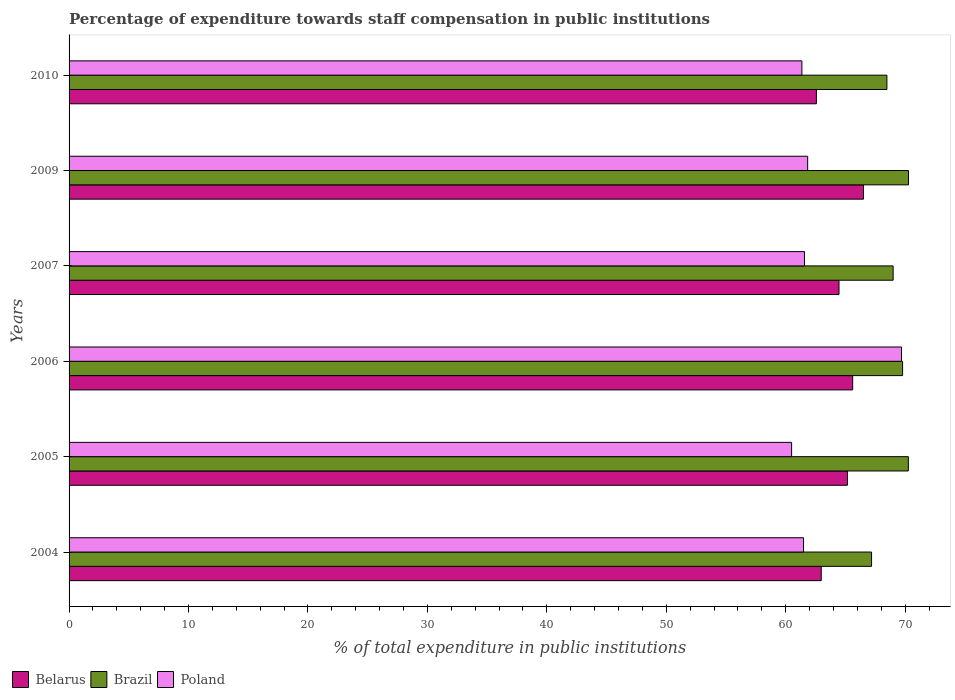How many groups of bars are there?
Provide a short and direct response. 6. Are the number of bars per tick equal to the number of legend labels?
Offer a terse response. Yes. Are the number of bars on each tick of the Y-axis equal?
Give a very brief answer. Yes. What is the percentage of expenditure towards staff compensation in Brazil in 2005?
Keep it short and to the point. 70.27. Across all years, what is the maximum percentage of expenditure towards staff compensation in Poland?
Offer a terse response. 69.7. Across all years, what is the minimum percentage of expenditure towards staff compensation in Poland?
Your answer should be very brief. 60.49. In which year was the percentage of expenditure towards staff compensation in Poland maximum?
Keep it short and to the point. 2006. In which year was the percentage of expenditure towards staff compensation in Poland minimum?
Your answer should be compact. 2005. What is the total percentage of expenditure towards staff compensation in Belarus in the graph?
Keep it short and to the point. 387.28. What is the difference between the percentage of expenditure towards staff compensation in Belarus in 2007 and that in 2010?
Offer a terse response. 1.89. What is the difference between the percentage of expenditure towards staff compensation in Poland in 2004 and the percentage of expenditure towards staff compensation in Belarus in 2005?
Give a very brief answer. -3.67. What is the average percentage of expenditure towards staff compensation in Belarus per year?
Give a very brief answer. 64.55. In the year 2009, what is the difference between the percentage of expenditure towards staff compensation in Poland and percentage of expenditure towards staff compensation in Belarus?
Ensure brevity in your answer.  -4.68. In how many years, is the percentage of expenditure towards staff compensation in Belarus greater than 64 %?
Offer a very short reply. 4. What is the ratio of the percentage of expenditure towards staff compensation in Brazil in 2006 to that in 2007?
Make the answer very short. 1.01. Is the percentage of expenditure towards staff compensation in Poland in 2005 less than that in 2007?
Your answer should be compact. Yes. What is the difference between the highest and the second highest percentage of expenditure towards staff compensation in Poland?
Your response must be concise. 7.86. What is the difference between the highest and the lowest percentage of expenditure towards staff compensation in Belarus?
Provide a short and direct response. 3.94. What does the 3rd bar from the bottom in 2006 represents?
Your response must be concise. Poland. How many years are there in the graph?
Offer a terse response. 6. What is the difference between two consecutive major ticks on the X-axis?
Your answer should be compact. 10. Where does the legend appear in the graph?
Your answer should be very brief. Bottom left. How are the legend labels stacked?
Your response must be concise. Horizontal. What is the title of the graph?
Your answer should be very brief. Percentage of expenditure towards staff compensation in public institutions. What is the label or title of the X-axis?
Make the answer very short. % of total expenditure in public institutions. What is the % of total expenditure in public institutions of Belarus in 2004?
Offer a terse response. 62.97. What is the % of total expenditure in public institutions of Brazil in 2004?
Your answer should be compact. 67.19. What is the % of total expenditure in public institutions in Poland in 2004?
Provide a succinct answer. 61.49. What is the % of total expenditure in public institutions in Belarus in 2005?
Offer a very short reply. 65.17. What is the % of total expenditure in public institutions of Brazil in 2005?
Your answer should be very brief. 70.27. What is the % of total expenditure in public institutions in Poland in 2005?
Your answer should be very brief. 60.49. What is the % of total expenditure in public institutions in Belarus in 2006?
Ensure brevity in your answer.  65.6. What is the % of total expenditure in public institutions in Brazil in 2006?
Your answer should be very brief. 69.78. What is the % of total expenditure in public institutions in Poland in 2006?
Keep it short and to the point. 69.7. What is the % of total expenditure in public institutions in Belarus in 2007?
Offer a very short reply. 64.46. What is the % of total expenditure in public institutions in Brazil in 2007?
Offer a very short reply. 68.99. What is the % of total expenditure in public institutions in Poland in 2007?
Provide a succinct answer. 61.57. What is the % of total expenditure in public institutions in Belarus in 2009?
Ensure brevity in your answer.  66.51. What is the % of total expenditure in public institutions in Brazil in 2009?
Provide a short and direct response. 70.28. What is the % of total expenditure in public institutions of Poland in 2009?
Your answer should be very brief. 61.84. What is the % of total expenditure in public institutions in Belarus in 2010?
Ensure brevity in your answer.  62.57. What is the % of total expenditure in public institutions in Brazil in 2010?
Provide a short and direct response. 68.47. What is the % of total expenditure in public institutions in Poland in 2010?
Provide a short and direct response. 61.35. Across all years, what is the maximum % of total expenditure in public institutions of Belarus?
Provide a short and direct response. 66.51. Across all years, what is the maximum % of total expenditure in public institutions of Brazil?
Offer a terse response. 70.28. Across all years, what is the maximum % of total expenditure in public institutions of Poland?
Keep it short and to the point. 69.7. Across all years, what is the minimum % of total expenditure in public institutions in Belarus?
Keep it short and to the point. 62.57. Across all years, what is the minimum % of total expenditure in public institutions in Brazil?
Give a very brief answer. 67.19. Across all years, what is the minimum % of total expenditure in public institutions of Poland?
Your answer should be very brief. 60.49. What is the total % of total expenditure in public institutions of Belarus in the graph?
Give a very brief answer. 387.28. What is the total % of total expenditure in public institutions in Brazil in the graph?
Give a very brief answer. 414.98. What is the total % of total expenditure in public institutions in Poland in the graph?
Ensure brevity in your answer.  376.44. What is the difference between the % of total expenditure in public institutions in Belarus in 2004 and that in 2005?
Provide a succinct answer. -2.19. What is the difference between the % of total expenditure in public institutions in Brazil in 2004 and that in 2005?
Offer a terse response. -3.08. What is the difference between the % of total expenditure in public institutions of Belarus in 2004 and that in 2006?
Provide a succinct answer. -2.63. What is the difference between the % of total expenditure in public institutions of Brazil in 2004 and that in 2006?
Your answer should be very brief. -2.6. What is the difference between the % of total expenditure in public institutions of Poland in 2004 and that in 2006?
Provide a short and direct response. -8.2. What is the difference between the % of total expenditure in public institutions in Belarus in 2004 and that in 2007?
Make the answer very short. -1.49. What is the difference between the % of total expenditure in public institutions in Brazil in 2004 and that in 2007?
Offer a terse response. -1.81. What is the difference between the % of total expenditure in public institutions in Poland in 2004 and that in 2007?
Make the answer very short. -0.08. What is the difference between the % of total expenditure in public institutions in Belarus in 2004 and that in 2009?
Ensure brevity in your answer.  -3.54. What is the difference between the % of total expenditure in public institutions in Brazil in 2004 and that in 2009?
Provide a short and direct response. -3.09. What is the difference between the % of total expenditure in public institutions in Poland in 2004 and that in 2009?
Your answer should be very brief. -0.34. What is the difference between the % of total expenditure in public institutions of Belarus in 2004 and that in 2010?
Offer a terse response. 0.41. What is the difference between the % of total expenditure in public institutions in Brazil in 2004 and that in 2010?
Ensure brevity in your answer.  -1.28. What is the difference between the % of total expenditure in public institutions in Poland in 2004 and that in 2010?
Give a very brief answer. 0.14. What is the difference between the % of total expenditure in public institutions in Belarus in 2005 and that in 2006?
Give a very brief answer. -0.44. What is the difference between the % of total expenditure in public institutions in Brazil in 2005 and that in 2006?
Ensure brevity in your answer.  0.48. What is the difference between the % of total expenditure in public institutions in Poland in 2005 and that in 2006?
Your answer should be very brief. -9.2. What is the difference between the % of total expenditure in public institutions in Belarus in 2005 and that in 2007?
Your response must be concise. 0.7. What is the difference between the % of total expenditure in public institutions in Brazil in 2005 and that in 2007?
Give a very brief answer. 1.27. What is the difference between the % of total expenditure in public institutions of Poland in 2005 and that in 2007?
Offer a very short reply. -1.08. What is the difference between the % of total expenditure in public institutions in Belarus in 2005 and that in 2009?
Ensure brevity in your answer.  -1.35. What is the difference between the % of total expenditure in public institutions in Brazil in 2005 and that in 2009?
Give a very brief answer. -0.01. What is the difference between the % of total expenditure in public institutions of Poland in 2005 and that in 2009?
Offer a terse response. -1.34. What is the difference between the % of total expenditure in public institutions of Belarus in 2005 and that in 2010?
Your answer should be compact. 2.6. What is the difference between the % of total expenditure in public institutions of Brazil in 2005 and that in 2010?
Provide a succinct answer. 1.8. What is the difference between the % of total expenditure in public institutions in Poland in 2005 and that in 2010?
Your answer should be compact. -0.86. What is the difference between the % of total expenditure in public institutions in Belarus in 2006 and that in 2007?
Offer a very short reply. 1.14. What is the difference between the % of total expenditure in public institutions of Brazil in 2006 and that in 2007?
Your answer should be very brief. 0.79. What is the difference between the % of total expenditure in public institutions in Poland in 2006 and that in 2007?
Keep it short and to the point. 8.12. What is the difference between the % of total expenditure in public institutions in Belarus in 2006 and that in 2009?
Provide a short and direct response. -0.91. What is the difference between the % of total expenditure in public institutions in Brazil in 2006 and that in 2009?
Make the answer very short. -0.5. What is the difference between the % of total expenditure in public institutions of Poland in 2006 and that in 2009?
Keep it short and to the point. 7.86. What is the difference between the % of total expenditure in public institutions of Belarus in 2006 and that in 2010?
Keep it short and to the point. 3.04. What is the difference between the % of total expenditure in public institutions of Brazil in 2006 and that in 2010?
Your response must be concise. 1.31. What is the difference between the % of total expenditure in public institutions in Poland in 2006 and that in 2010?
Keep it short and to the point. 8.34. What is the difference between the % of total expenditure in public institutions of Belarus in 2007 and that in 2009?
Your response must be concise. -2.05. What is the difference between the % of total expenditure in public institutions of Brazil in 2007 and that in 2009?
Provide a short and direct response. -1.29. What is the difference between the % of total expenditure in public institutions in Poland in 2007 and that in 2009?
Your answer should be very brief. -0.26. What is the difference between the % of total expenditure in public institutions in Belarus in 2007 and that in 2010?
Your answer should be compact. 1.89. What is the difference between the % of total expenditure in public institutions in Brazil in 2007 and that in 2010?
Offer a terse response. 0.52. What is the difference between the % of total expenditure in public institutions of Poland in 2007 and that in 2010?
Ensure brevity in your answer.  0.22. What is the difference between the % of total expenditure in public institutions in Belarus in 2009 and that in 2010?
Your response must be concise. 3.94. What is the difference between the % of total expenditure in public institutions in Brazil in 2009 and that in 2010?
Offer a very short reply. 1.81. What is the difference between the % of total expenditure in public institutions of Poland in 2009 and that in 2010?
Make the answer very short. 0.48. What is the difference between the % of total expenditure in public institutions of Belarus in 2004 and the % of total expenditure in public institutions of Brazil in 2005?
Ensure brevity in your answer.  -7.29. What is the difference between the % of total expenditure in public institutions in Belarus in 2004 and the % of total expenditure in public institutions in Poland in 2005?
Offer a very short reply. 2.48. What is the difference between the % of total expenditure in public institutions in Brazil in 2004 and the % of total expenditure in public institutions in Poland in 2005?
Ensure brevity in your answer.  6.69. What is the difference between the % of total expenditure in public institutions in Belarus in 2004 and the % of total expenditure in public institutions in Brazil in 2006?
Ensure brevity in your answer.  -6.81. What is the difference between the % of total expenditure in public institutions of Belarus in 2004 and the % of total expenditure in public institutions of Poland in 2006?
Give a very brief answer. -6.72. What is the difference between the % of total expenditure in public institutions in Brazil in 2004 and the % of total expenditure in public institutions in Poland in 2006?
Keep it short and to the point. -2.51. What is the difference between the % of total expenditure in public institutions in Belarus in 2004 and the % of total expenditure in public institutions in Brazil in 2007?
Your response must be concise. -6.02. What is the difference between the % of total expenditure in public institutions of Belarus in 2004 and the % of total expenditure in public institutions of Poland in 2007?
Provide a succinct answer. 1.4. What is the difference between the % of total expenditure in public institutions of Brazil in 2004 and the % of total expenditure in public institutions of Poland in 2007?
Provide a succinct answer. 5.61. What is the difference between the % of total expenditure in public institutions in Belarus in 2004 and the % of total expenditure in public institutions in Brazil in 2009?
Your answer should be compact. -7.31. What is the difference between the % of total expenditure in public institutions in Belarus in 2004 and the % of total expenditure in public institutions in Poland in 2009?
Provide a succinct answer. 1.14. What is the difference between the % of total expenditure in public institutions of Brazil in 2004 and the % of total expenditure in public institutions of Poland in 2009?
Your response must be concise. 5.35. What is the difference between the % of total expenditure in public institutions of Belarus in 2004 and the % of total expenditure in public institutions of Brazil in 2010?
Give a very brief answer. -5.5. What is the difference between the % of total expenditure in public institutions in Belarus in 2004 and the % of total expenditure in public institutions in Poland in 2010?
Offer a very short reply. 1.62. What is the difference between the % of total expenditure in public institutions in Brazil in 2004 and the % of total expenditure in public institutions in Poland in 2010?
Your answer should be very brief. 5.83. What is the difference between the % of total expenditure in public institutions of Belarus in 2005 and the % of total expenditure in public institutions of Brazil in 2006?
Offer a very short reply. -4.62. What is the difference between the % of total expenditure in public institutions of Belarus in 2005 and the % of total expenditure in public institutions of Poland in 2006?
Your response must be concise. -4.53. What is the difference between the % of total expenditure in public institutions in Brazil in 2005 and the % of total expenditure in public institutions in Poland in 2006?
Your response must be concise. 0.57. What is the difference between the % of total expenditure in public institutions of Belarus in 2005 and the % of total expenditure in public institutions of Brazil in 2007?
Offer a terse response. -3.83. What is the difference between the % of total expenditure in public institutions of Belarus in 2005 and the % of total expenditure in public institutions of Poland in 2007?
Keep it short and to the point. 3.59. What is the difference between the % of total expenditure in public institutions in Brazil in 2005 and the % of total expenditure in public institutions in Poland in 2007?
Keep it short and to the point. 8.69. What is the difference between the % of total expenditure in public institutions of Belarus in 2005 and the % of total expenditure in public institutions of Brazil in 2009?
Ensure brevity in your answer.  -5.12. What is the difference between the % of total expenditure in public institutions of Belarus in 2005 and the % of total expenditure in public institutions of Poland in 2009?
Make the answer very short. 3.33. What is the difference between the % of total expenditure in public institutions in Brazil in 2005 and the % of total expenditure in public institutions in Poland in 2009?
Ensure brevity in your answer.  8.43. What is the difference between the % of total expenditure in public institutions of Belarus in 2005 and the % of total expenditure in public institutions of Brazil in 2010?
Your response must be concise. -3.31. What is the difference between the % of total expenditure in public institutions in Belarus in 2005 and the % of total expenditure in public institutions in Poland in 2010?
Provide a succinct answer. 3.81. What is the difference between the % of total expenditure in public institutions of Brazil in 2005 and the % of total expenditure in public institutions of Poland in 2010?
Offer a terse response. 8.91. What is the difference between the % of total expenditure in public institutions in Belarus in 2006 and the % of total expenditure in public institutions in Brazil in 2007?
Your answer should be compact. -3.39. What is the difference between the % of total expenditure in public institutions in Belarus in 2006 and the % of total expenditure in public institutions in Poland in 2007?
Your response must be concise. 4.03. What is the difference between the % of total expenditure in public institutions in Brazil in 2006 and the % of total expenditure in public institutions in Poland in 2007?
Offer a very short reply. 8.21. What is the difference between the % of total expenditure in public institutions of Belarus in 2006 and the % of total expenditure in public institutions of Brazil in 2009?
Offer a terse response. -4.68. What is the difference between the % of total expenditure in public institutions in Belarus in 2006 and the % of total expenditure in public institutions in Poland in 2009?
Keep it short and to the point. 3.77. What is the difference between the % of total expenditure in public institutions in Brazil in 2006 and the % of total expenditure in public institutions in Poland in 2009?
Offer a very short reply. 7.95. What is the difference between the % of total expenditure in public institutions in Belarus in 2006 and the % of total expenditure in public institutions in Brazil in 2010?
Keep it short and to the point. -2.87. What is the difference between the % of total expenditure in public institutions of Belarus in 2006 and the % of total expenditure in public institutions of Poland in 2010?
Provide a short and direct response. 4.25. What is the difference between the % of total expenditure in public institutions in Brazil in 2006 and the % of total expenditure in public institutions in Poland in 2010?
Provide a succinct answer. 8.43. What is the difference between the % of total expenditure in public institutions of Belarus in 2007 and the % of total expenditure in public institutions of Brazil in 2009?
Your answer should be very brief. -5.82. What is the difference between the % of total expenditure in public institutions in Belarus in 2007 and the % of total expenditure in public institutions in Poland in 2009?
Keep it short and to the point. 2.63. What is the difference between the % of total expenditure in public institutions in Brazil in 2007 and the % of total expenditure in public institutions in Poland in 2009?
Keep it short and to the point. 7.16. What is the difference between the % of total expenditure in public institutions of Belarus in 2007 and the % of total expenditure in public institutions of Brazil in 2010?
Give a very brief answer. -4.01. What is the difference between the % of total expenditure in public institutions in Belarus in 2007 and the % of total expenditure in public institutions in Poland in 2010?
Make the answer very short. 3.11. What is the difference between the % of total expenditure in public institutions in Brazil in 2007 and the % of total expenditure in public institutions in Poland in 2010?
Your answer should be compact. 7.64. What is the difference between the % of total expenditure in public institutions of Belarus in 2009 and the % of total expenditure in public institutions of Brazil in 2010?
Give a very brief answer. -1.96. What is the difference between the % of total expenditure in public institutions in Belarus in 2009 and the % of total expenditure in public institutions in Poland in 2010?
Provide a succinct answer. 5.16. What is the difference between the % of total expenditure in public institutions in Brazil in 2009 and the % of total expenditure in public institutions in Poland in 2010?
Your answer should be compact. 8.93. What is the average % of total expenditure in public institutions of Belarus per year?
Keep it short and to the point. 64.55. What is the average % of total expenditure in public institutions of Brazil per year?
Your answer should be very brief. 69.16. What is the average % of total expenditure in public institutions in Poland per year?
Provide a short and direct response. 62.74. In the year 2004, what is the difference between the % of total expenditure in public institutions in Belarus and % of total expenditure in public institutions in Brazil?
Keep it short and to the point. -4.21. In the year 2004, what is the difference between the % of total expenditure in public institutions of Belarus and % of total expenditure in public institutions of Poland?
Provide a succinct answer. 1.48. In the year 2004, what is the difference between the % of total expenditure in public institutions in Brazil and % of total expenditure in public institutions in Poland?
Your answer should be compact. 5.69. In the year 2005, what is the difference between the % of total expenditure in public institutions of Belarus and % of total expenditure in public institutions of Brazil?
Your answer should be compact. -5.1. In the year 2005, what is the difference between the % of total expenditure in public institutions in Belarus and % of total expenditure in public institutions in Poland?
Your answer should be very brief. 4.67. In the year 2005, what is the difference between the % of total expenditure in public institutions of Brazil and % of total expenditure in public institutions of Poland?
Provide a short and direct response. 9.77. In the year 2006, what is the difference between the % of total expenditure in public institutions of Belarus and % of total expenditure in public institutions of Brazil?
Ensure brevity in your answer.  -4.18. In the year 2006, what is the difference between the % of total expenditure in public institutions in Belarus and % of total expenditure in public institutions in Poland?
Provide a succinct answer. -4.09. In the year 2006, what is the difference between the % of total expenditure in public institutions in Brazil and % of total expenditure in public institutions in Poland?
Your response must be concise. 0.09. In the year 2007, what is the difference between the % of total expenditure in public institutions of Belarus and % of total expenditure in public institutions of Brazil?
Make the answer very short. -4.53. In the year 2007, what is the difference between the % of total expenditure in public institutions of Belarus and % of total expenditure in public institutions of Poland?
Offer a very short reply. 2.89. In the year 2007, what is the difference between the % of total expenditure in public institutions in Brazil and % of total expenditure in public institutions in Poland?
Give a very brief answer. 7.42. In the year 2009, what is the difference between the % of total expenditure in public institutions of Belarus and % of total expenditure in public institutions of Brazil?
Keep it short and to the point. -3.77. In the year 2009, what is the difference between the % of total expenditure in public institutions in Belarus and % of total expenditure in public institutions in Poland?
Give a very brief answer. 4.68. In the year 2009, what is the difference between the % of total expenditure in public institutions in Brazil and % of total expenditure in public institutions in Poland?
Keep it short and to the point. 8.45. In the year 2010, what is the difference between the % of total expenditure in public institutions in Belarus and % of total expenditure in public institutions in Brazil?
Give a very brief answer. -5.9. In the year 2010, what is the difference between the % of total expenditure in public institutions in Belarus and % of total expenditure in public institutions in Poland?
Provide a short and direct response. 1.21. In the year 2010, what is the difference between the % of total expenditure in public institutions in Brazil and % of total expenditure in public institutions in Poland?
Provide a short and direct response. 7.12. What is the ratio of the % of total expenditure in public institutions in Belarus in 2004 to that in 2005?
Provide a succinct answer. 0.97. What is the ratio of the % of total expenditure in public institutions in Brazil in 2004 to that in 2005?
Your answer should be very brief. 0.96. What is the ratio of the % of total expenditure in public institutions in Poland in 2004 to that in 2005?
Offer a very short reply. 1.02. What is the ratio of the % of total expenditure in public institutions of Belarus in 2004 to that in 2006?
Provide a short and direct response. 0.96. What is the ratio of the % of total expenditure in public institutions in Brazil in 2004 to that in 2006?
Your answer should be very brief. 0.96. What is the ratio of the % of total expenditure in public institutions in Poland in 2004 to that in 2006?
Provide a succinct answer. 0.88. What is the ratio of the % of total expenditure in public institutions in Belarus in 2004 to that in 2007?
Provide a short and direct response. 0.98. What is the ratio of the % of total expenditure in public institutions of Brazil in 2004 to that in 2007?
Offer a very short reply. 0.97. What is the ratio of the % of total expenditure in public institutions in Poland in 2004 to that in 2007?
Give a very brief answer. 1. What is the ratio of the % of total expenditure in public institutions of Belarus in 2004 to that in 2009?
Provide a succinct answer. 0.95. What is the ratio of the % of total expenditure in public institutions in Brazil in 2004 to that in 2009?
Offer a very short reply. 0.96. What is the ratio of the % of total expenditure in public institutions of Poland in 2004 to that in 2009?
Offer a very short reply. 0.99. What is the ratio of the % of total expenditure in public institutions in Belarus in 2004 to that in 2010?
Your answer should be compact. 1.01. What is the ratio of the % of total expenditure in public institutions in Brazil in 2004 to that in 2010?
Give a very brief answer. 0.98. What is the ratio of the % of total expenditure in public institutions of Poland in 2004 to that in 2010?
Provide a short and direct response. 1. What is the ratio of the % of total expenditure in public institutions of Belarus in 2005 to that in 2006?
Your response must be concise. 0.99. What is the ratio of the % of total expenditure in public institutions in Brazil in 2005 to that in 2006?
Your answer should be very brief. 1.01. What is the ratio of the % of total expenditure in public institutions of Poland in 2005 to that in 2006?
Give a very brief answer. 0.87. What is the ratio of the % of total expenditure in public institutions of Belarus in 2005 to that in 2007?
Give a very brief answer. 1.01. What is the ratio of the % of total expenditure in public institutions in Brazil in 2005 to that in 2007?
Provide a succinct answer. 1.02. What is the ratio of the % of total expenditure in public institutions in Poland in 2005 to that in 2007?
Your answer should be very brief. 0.98. What is the ratio of the % of total expenditure in public institutions in Belarus in 2005 to that in 2009?
Provide a succinct answer. 0.98. What is the ratio of the % of total expenditure in public institutions in Brazil in 2005 to that in 2009?
Offer a very short reply. 1. What is the ratio of the % of total expenditure in public institutions of Poland in 2005 to that in 2009?
Ensure brevity in your answer.  0.98. What is the ratio of the % of total expenditure in public institutions of Belarus in 2005 to that in 2010?
Keep it short and to the point. 1.04. What is the ratio of the % of total expenditure in public institutions of Brazil in 2005 to that in 2010?
Ensure brevity in your answer.  1.03. What is the ratio of the % of total expenditure in public institutions in Belarus in 2006 to that in 2007?
Offer a terse response. 1.02. What is the ratio of the % of total expenditure in public institutions of Brazil in 2006 to that in 2007?
Offer a very short reply. 1.01. What is the ratio of the % of total expenditure in public institutions of Poland in 2006 to that in 2007?
Your answer should be very brief. 1.13. What is the ratio of the % of total expenditure in public institutions of Belarus in 2006 to that in 2009?
Give a very brief answer. 0.99. What is the ratio of the % of total expenditure in public institutions of Brazil in 2006 to that in 2009?
Offer a very short reply. 0.99. What is the ratio of the % of total expenditure in public institutions in Poland in 2006 to that in 2009?
Keep it short and to the point. 1.13. What is the ratio of the % of total expenditure in public institutions in Belarus in 2006 to that in 2010?
Keep it short and to the point. 1.05. What is the ratio of the % of total expenditure in public institutions of Brazil in 2006 to that in 2010?
Ensure brevity in your answer.  1.02. What is the ratio of the % of total expenditure in public institutions in Poland in 2006 to that in 2010?
Your answer should be very brief. 1.14. What is the ratio of the % of total expenditure in public institutions in Belarus in 2007 to that in 2009?
Give a very brief answer. 0.97. What is the ratio of the % of total expenditure in public institutions of Brazil in 2007 to that in 2009?
Ensure brevity in your answer.  0.98. What is the ratio of the % of total expenditure in public institutions in Belarus in 2007 to that in 2010?
Your answer should be very brief. 1.03. What is the ratio of the % of total expenditure in public institutions of Brazil in 2007 to that in 2010?
Your answer should be very brief. 1.01. What is the ratio of the % of total expenditure in public institutions of Poland in 2007 to that in 2010?
Offer a very short reply. 1. What is the ratio of the % of total expenditure in public institutions in Belarus in 2009 to that in 2010?
Keep it short and to the point. 1.06. What is the ratio of the % of total expenditure in public institutions of Brazil in 2009 to that in 2010?
Your response must be concise. 1.03. What is the ratio of the % of total expenditure in public institutions of Poland in 2009 to that in 2010?
Your response must be concise. 1.01. What is the difference between the highest and the second highest % of total expenditure in public institutions in Belarus?
Give a very brief answer. 0.91. What is the difference between the highest and the second highest % of total expenditure in public institutions of Brazil?
Ensure brevity in your answer.  0.01. What is the difference between the highest and the second highest % of total expenditure in public institutions of Poland?
Give a very brief answer. 7.86. What is the difference between the highest and the lowest % of total expenditure in public institutions of Belarus?
Provide a short and direct response. 3.94. What is the difference between the highest and the lowest % of total expenditure in public institutions of Brazil?
Ensure brevity in your answer.  3.09. What is the difference between the highest and the lowest % of total expenditure in public institutions of Poland?
Your answer should be compact. 9.2. 